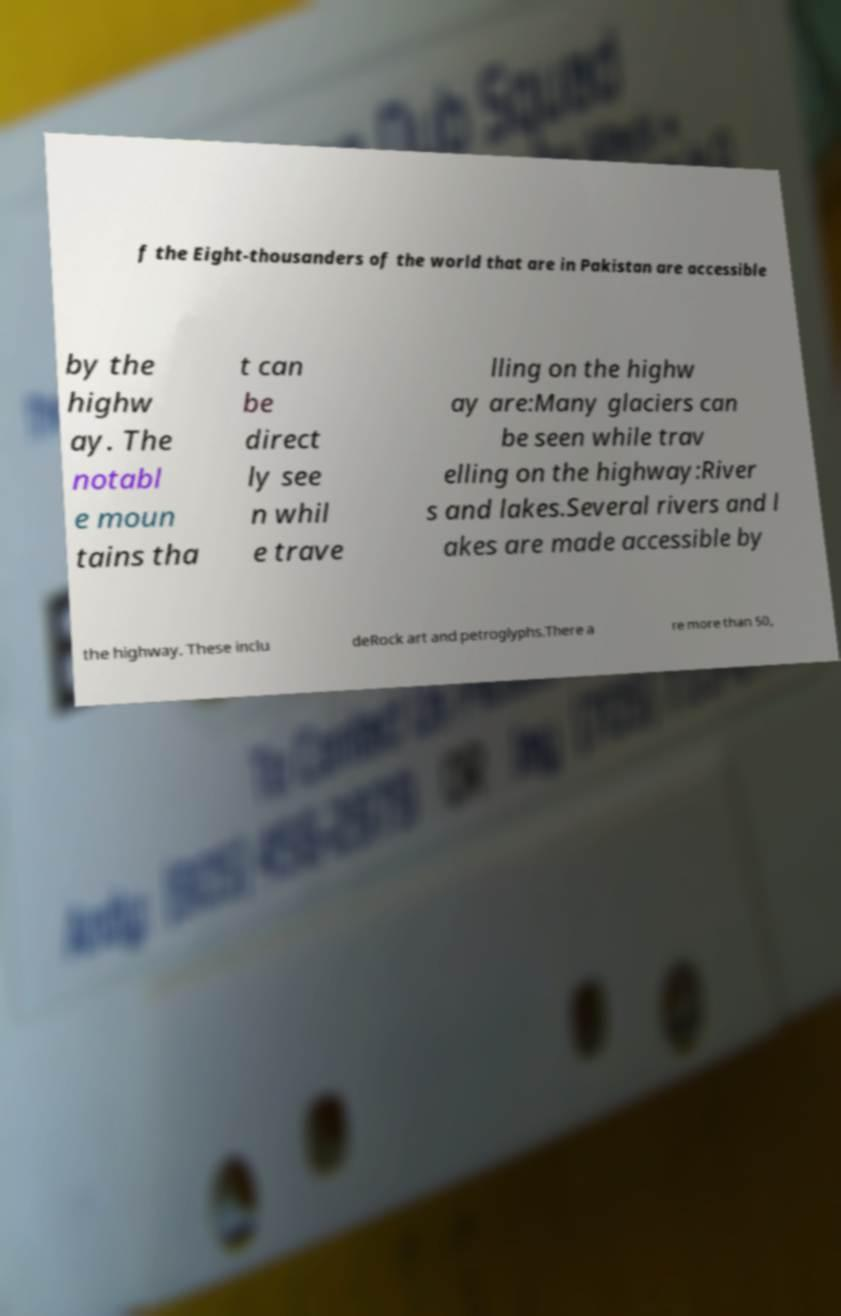There's text embedded in this image that I need extracted. Can you transcribe it verbatim? f the Eight-thousanders of the world that are in Pakistan are accessible by the highw ay. The notabl e moun tains tha t can be direct ly see n whil e trave lling on the highw ay are:Many glaciers can be seen while trav elling on the highway:River s and lakes.Several rivers and l akes are made accessible by the highway. These inclu deRock art and petroglyphs.There a re more than 50, 